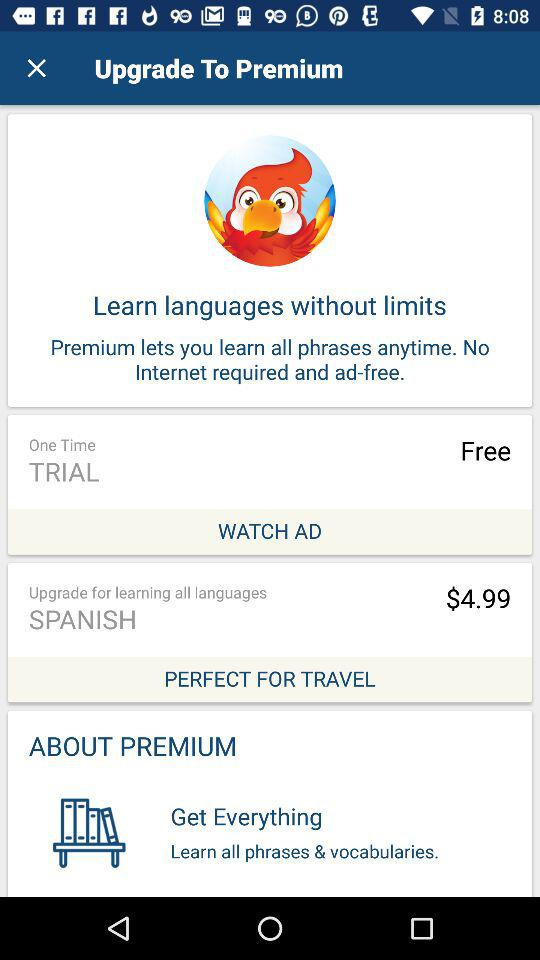How many languages can I learn with premium?
Answer the question using a single word or phrase. All languages 